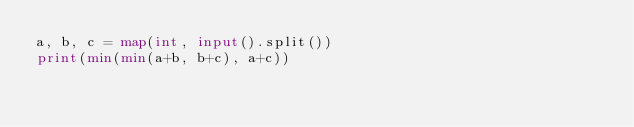<code> <loc_0><loc_0><loc_500><loc_500><_Python_>a, b, c = map(int, input().split())
print(min(min(a+b, b+c), a+c))</code> 